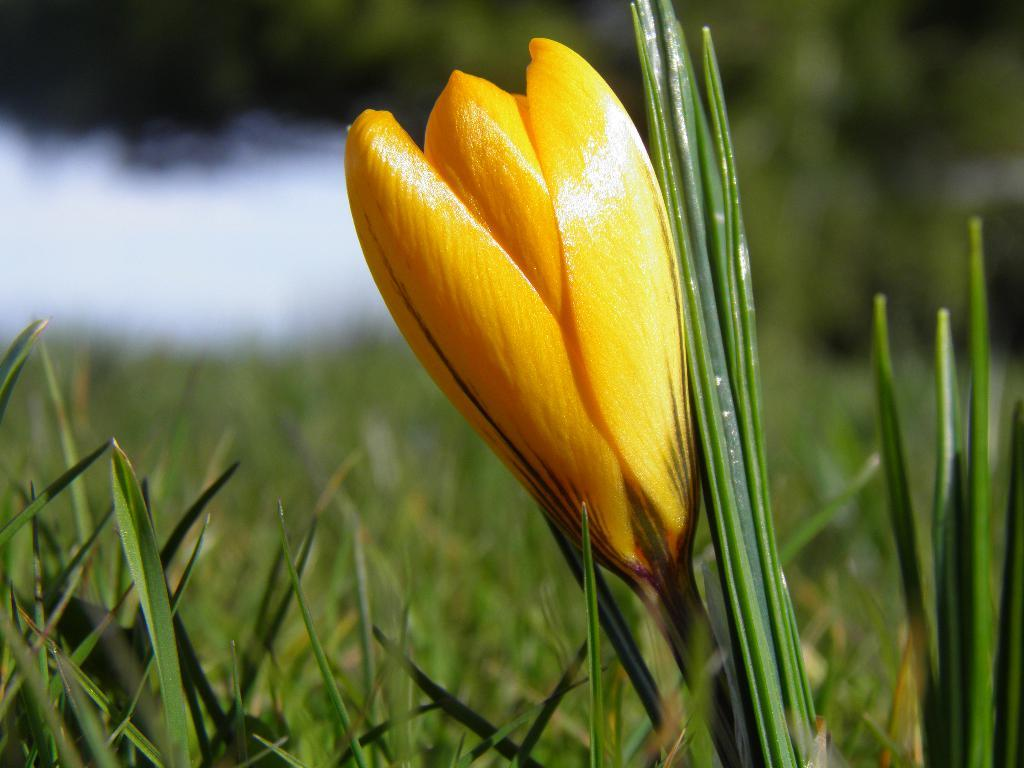What type of flower is in the image? There is a yellow flower in the image. Where is the flower located? The flower is on a plant. What color is the background behind the flower? The background of the flower is blue. What advice does the mom give about the flower's distribution in the image? There is no mention of a mom or any advice in the image, as it only features a yellow flower on a plant with a blue background. 